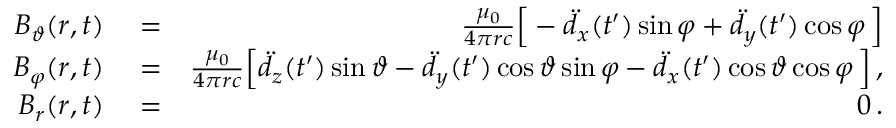<formula> <loc_0><loc_0><loc_500><loc_500>\begin{array} { r l r } { B _ { \vartheta } ( r , t ) } & = } & { \frac { \mu _ { 0 } } { 4 \pi r c } \left [ - \ddot { d } _ { x } ( t ^ { \prime } ) \sin \varphi + \ddot { d } _ { y } ( t ^ { \prime } ) \cos \varphi \, \right ] } \\ { B _ { \varphi } ( r , t ) } & = } & { \frac { \mu _ { 0 } } { 4 \pi r c } \left [ \ddot { d } _ { z } ( t ^ { \prime } ) \sin \vartheta - \ddot { d } _ { y } ( t ^ { \prime } ) \cos \vartheta \sin \varphi - \ddot { d } _ { x } ( t ^ { \prime } ) \cos \vartheta \cos \varphi \, \right ] \, , } \\ { B _ { r } ( r , t ) } & = } & { 0 \, . } \end{array}</formula> 